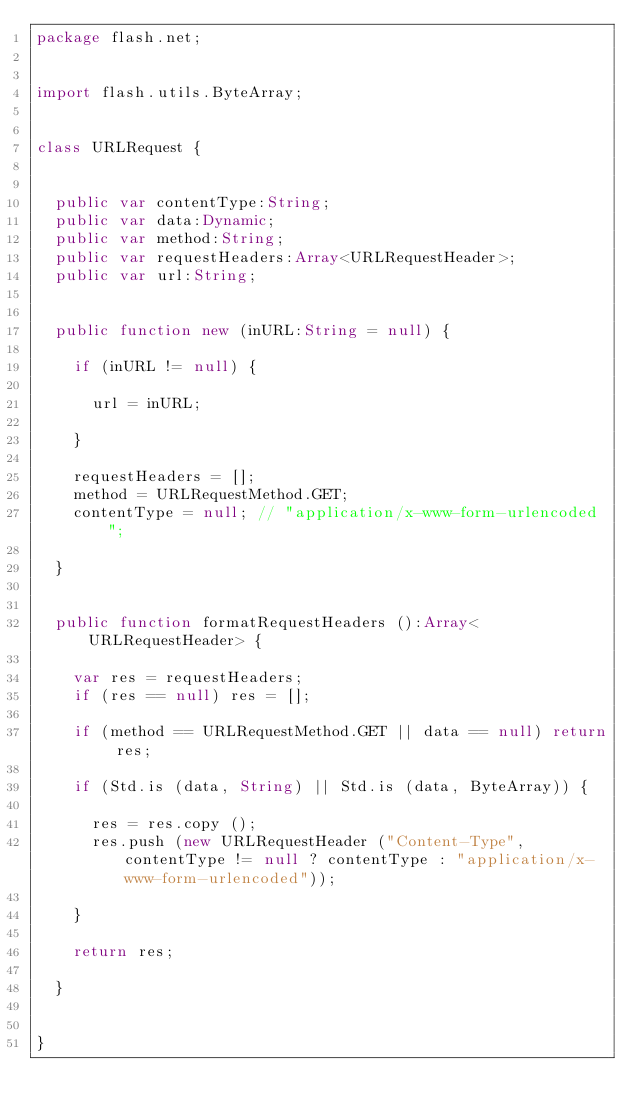<code> <loc_0><loc_0><loc_500><loc_500><_Haxe_>package flash.net;


import flash.utils.ByteArray;


class URLRequest {
	
	
	public var contentType:String;
	public var data:Dynamic;
	public var method:String;
	public var requestHeaders:Array<URLRequestHeader>;
	public var url:String;
	
	
	public function new (inURL:String = null) {
		
		if (inURL != null) {
			
			url = inURL;
			
		}
		
		requestHeaders = [];
		method = URLRequestMethod.GET;
		contentType = null; // "application/x-www-form-urlencoded";
		
	}
	
	
	public function formatRequestHeaders ():Array<URLRequestHeader> {
		
		var res = requestHeaders;
		if (res == null) res = [];
		
		if (method == URLRequestMethod.GET || data == null) return res;
		
		if (Std.is (data, String) || Std.is (data, ByteArray)) {
			
			res = res.copy ();
			res.push (new URLRequestHeader ("Content-Type", contentType != null ? contentType : "application/x-www-form-urlencoded"));
			
		}
		
		return res;
		
	}
	
	
}</code> 